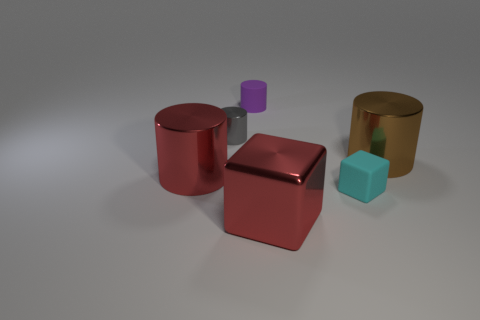There is a small matte thing that is in front of the brown cylinder; is it the same shape as the rubber object that is behind the small cyan cube?
Your response must be concise. No. Does the purple rubber thing have the same size as the shiny cylinder that is right of the tiny gray cylinder?
Offer a terse response. No. Are there more rubber balls than red metallic blocks?
Make the answer very short. No. Are the red cylinder behind the small block and the large object that is behind the big red metal cylinder made of the same material?
Your answer should be compact. Yes. What material is the large brown cylinder?
Keep it short and to the point. Metal. Is the number of cyan blocks behind the tiny rubber cylinder greater than the number of small purple matte cubes?
Your answer should be compact. No. There is a large cylinder to the right of the big metallic object that is in front of the large red cylinder; how many large red cylinders are in front of it?
Provide a succinct answer. 1. The big thing that is both behind the cyan thing and to the left of the cyan object is made of what material?
Provide a succinct answer. Metal. The tiny metallic cylinder is what color?
Your answer should be very brief. Gray. Are there more big red cubes that are in front of the tiny metal object than big metallic cylinders to the left of the big red cylinder?
Your answer should be very brief. Yes. 